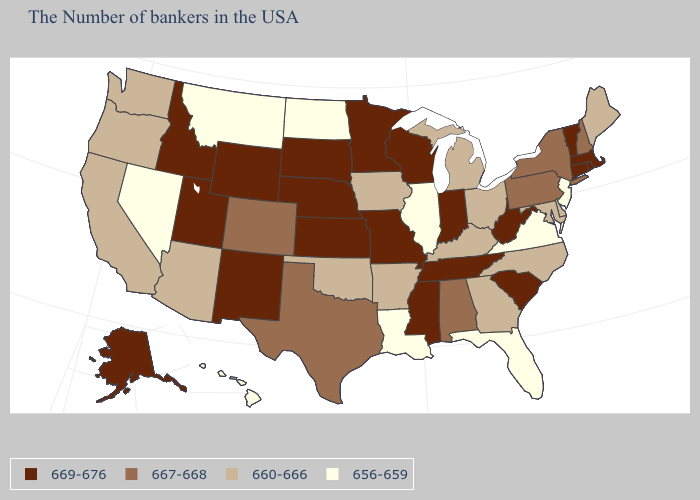Name the states that have a value in the range 669-676?
Answer briefly. Massachusetts, Rhode Island, Vermont, Connecticut, South Carolina, West Virginia, Indiana, Tennessee, Wisconsin, Mississippi, Missouri, Minnesota, Kansas, Nebraska, South Dakota, Wyoming, New Mexico, Utah, Idaho, Alaska. Does Alaska have a higher value than Montana?
Answer briefly. Yes. What is the lowest value in the USA?
Short answer required. 656-659. What is the value of Maryland?
Write a very short answer. 660-666. What is the value of New Jersey?
Write a very short answer. 656-659. What is the highest value in the USA?
Quick response, please. 669-676. Which states have the highest value in the USA?
Write a very short answer. Massachusetts, Rhode Island, Vermont, Connecticut, South Carolina, West Virginia, Indiana, Tennessee, Wisconsin, Mississippi, Missouri, Minnesota, Kansas, Nebraska, South Dakota, Wyoming, New Mexico, Utah, Idaho, Alaska. Name the states that have a value in the range 656-659?
Be succinct. New Jersey, Virginia, Florida, Illinois, Louisiana, North Dakota, Montana, Nevada, Hawaii. Among the states that border Wyoming , which have the highest value?
Give a very brief answer. Nebraska, South Dakota, Utah, Idaho. Which states hav the highest value in the West?
Give a very brief answer. Wyoming, New Mexico, Utah, Idaho, Alaska. Does Colorado have the lowest value in the West?
Give a very brief answer. No. Name the states that have a value in the range 667-668?
Keep it brief. New Hampshire, New York, Pennsylvania, Alabama, Texas, Colorado. Which states have the lowest value in the West?
Be succinct. Montana, Nevada, Hawaii. Does Washington have the highest value in the West?
Quick response, please. No. Name the states that have a value in the range 656-659?
Short answer required. New Jersey, Virginia, Florida, Illinois, Louisiana, North Dakota, Montana, Nevada, Hawaii. 